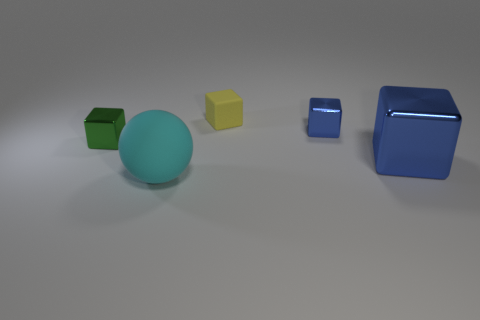Add 4 small brown things. How many objects exist? 9 Subtract all balls. How many objects are left? 4 Add 4 large matte spheres. How many large matte spheres are left? 5 Add 4 big yellow matte cubes. How many big yellow matte cubes exist? 4 Subtract 1 cyan spheres. How many objects are left? 4 Subtract all yellow metallic balls. Subtract all small blue objects. How many objects are left? 4 